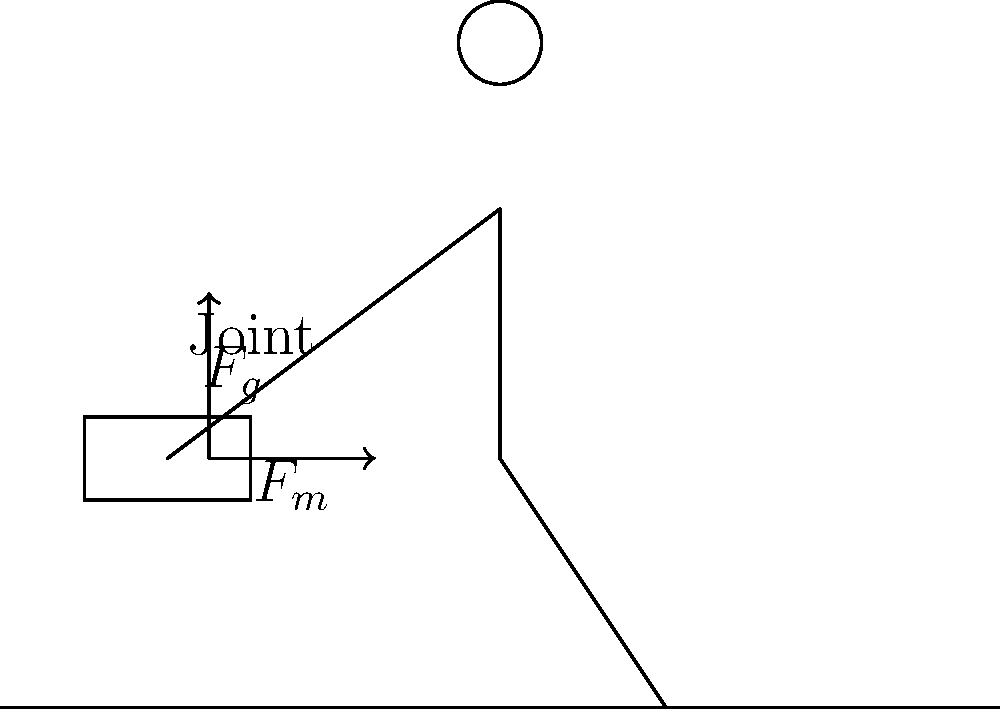A firefighter is carrying heavy equipment while responding to a wildfire. The equipment weighs 50 lbs (22.7 kg) and is held at arm's length. If the firefighter's arm is at a 30-degree angle from vertical, what is the approximate torque acting on the shoulder joint? Assume the center of mass of the equipment is 2 feet (0.61 m) from the shoulder joint. To calculate the torque on the shoulder joint, we need to follow these steps:

1. Identify the force: The force is the weight of the equipment, $F = mg$.
   $F = 22.7 \text{ kg} \times 9.8 \text{ m/s}^2 = 222.46 \text{ N}$

2. Calculate the moment arm: This is the perpendicular distance from the line of action of the force to the axis of rotation (shoulder joint).
   Moment arm $= 0.61 \text{ m} \times \sin(30°) = 0.305 \text{ m}$

3. Calculate the torque: Torque $\tau = F \times d$, where $F$ is the force and $d$ is the moment arm.
   $\tau = 222.46 \text{ N} \times 0.305 \text{ m} = 67.85 \text{ N·m}$

This torque places significant stress on the firefighter's shoulder joint, which can lead to fatigue and potential injury over time, especially in the challenging conditions of wildfire response.
Answer: Approximately 68 N·m 